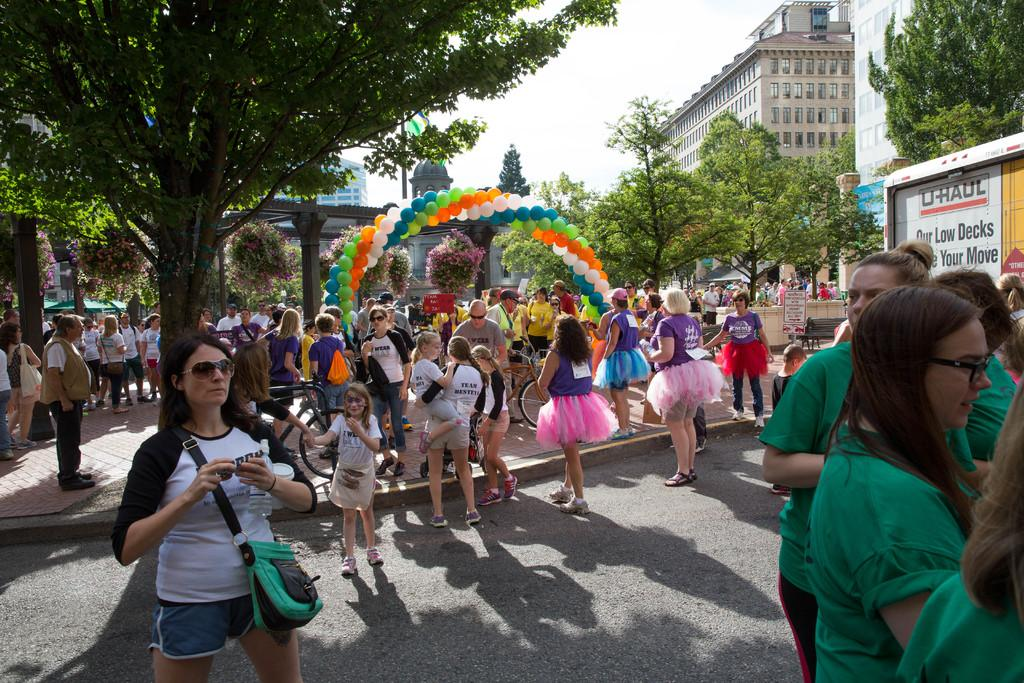What can be seen on the road in the image? There are people on the road in the image. What else is present in the image besides people on the road? There are balloons, trees, buildings, and the sky visible in the image. Can you describe the type of vegetation in the image? There are trees in the image. What is visible in the background of the image? There are buildings and the sky visible in the background of the image. What month is it in the image, based on the behavior of the chickens? There are no chickens present in the image, so it is not possible to determine the month based on their behavior. 